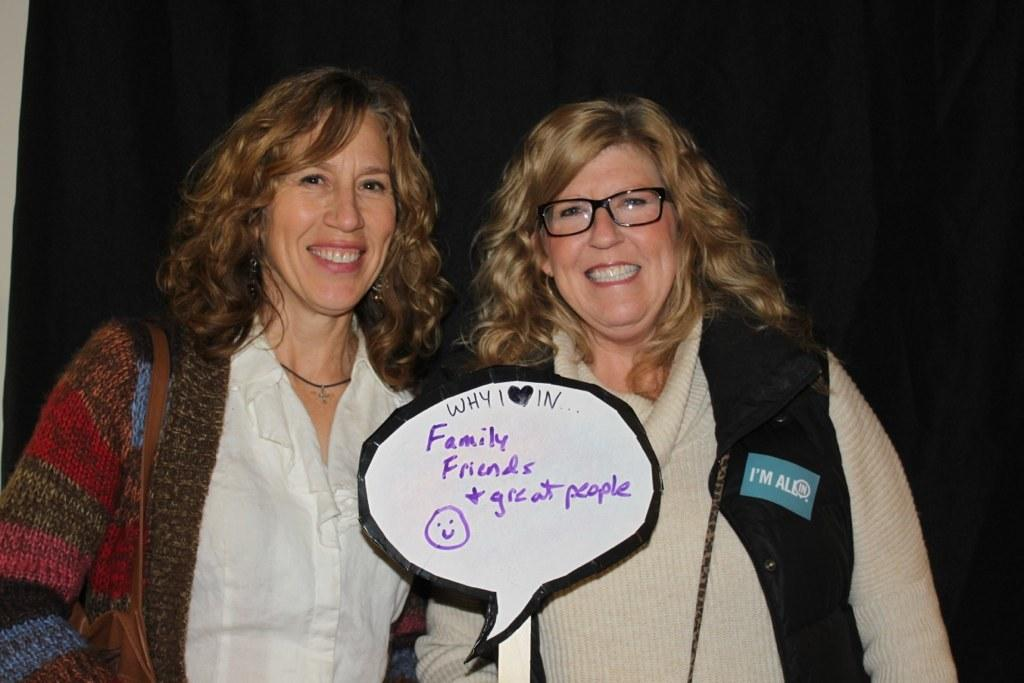How many women are in the image? There are two women in the image. What are the women doing in the image? The women are standing and holding a board. What is the facial expression of the women in the image? The women are smiling in the image. Can you describe the appearance of one of the women? One of the women is wearing spectacles. What is the color of the background in the image? The background of the image is black. What type of swing can be seen in the image? There is no swing present in the image. How does the fifth woman in the image contribute to the scene? There are only two women in the image, so there is no fifth woman to contribute to the scene. 